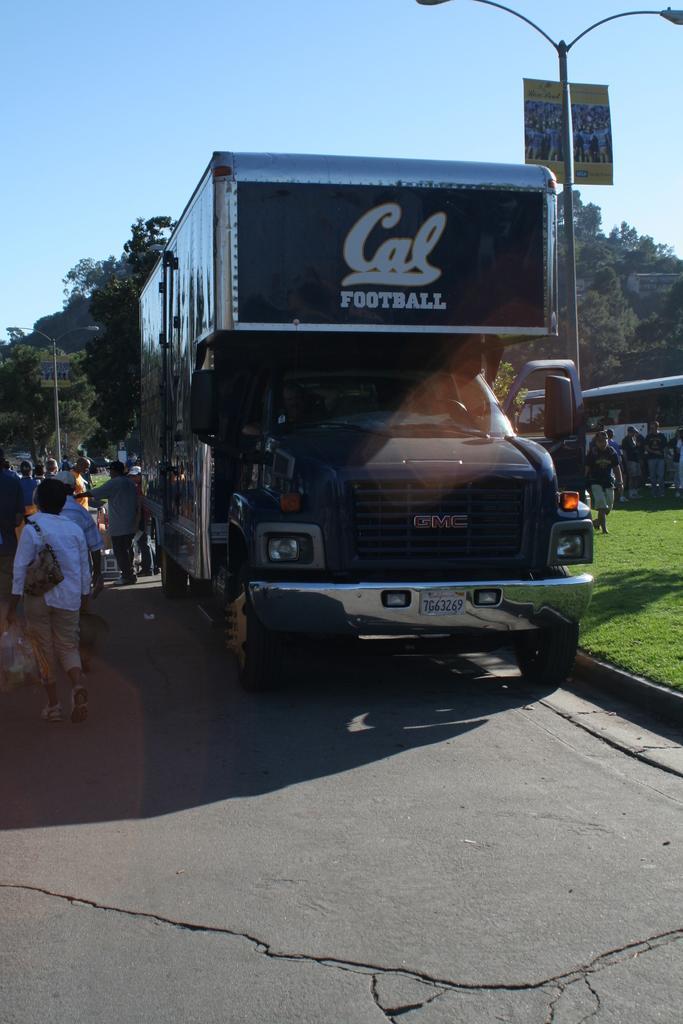Can you describe this image briefly? In this image we can see motor vehicle, persons standing on the road, ground, shed, trees, street pole, street lights and sky. 